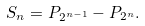Convert formula to latex. <formula><loc_0><loc_0><loc_500><loc_500>S _ { n } = P _ { 2 ^ { n - 1 } } - P _ { 2 ^ { n } } .</formula> 